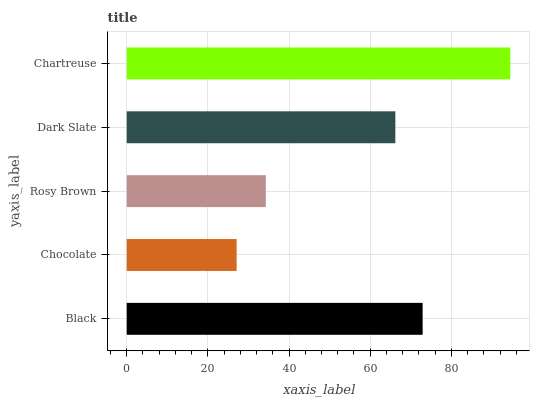Is Chocolate the minimum?
Answer yes or no. Yes. Is Chartreuse the maximum?
Answer yes or no. Yes. Is Rosy Brown the minimum?
Answer yes or no. No. Is Rosy Brown the maximum?
Answer yes or no. No. Is Rosy Brown greater than Chocolate?
Answer yes or no. Yes. Is Chocolate less than Rosy Brown?
Answer yes or no. Yes. Is Chocolate greater than Rosy Brown?
Answer yes or no. No. Is Rosy Brown less than Chocolate?
Answer yes or no. No. Is Dark Slate the high median?
Answer yes or no. Yes. Is Dark Slate the low median?
Answer yes or no. Yes. Is Rosy Brown the high median?
Answer yes or no. No. Is Chocolate the low median?
Answer yes or no. No. 